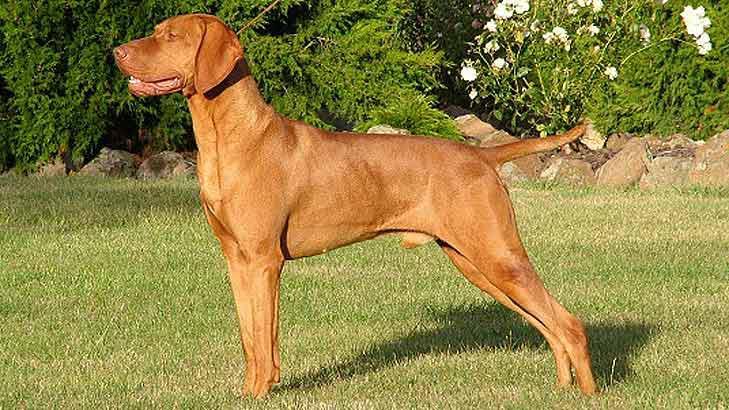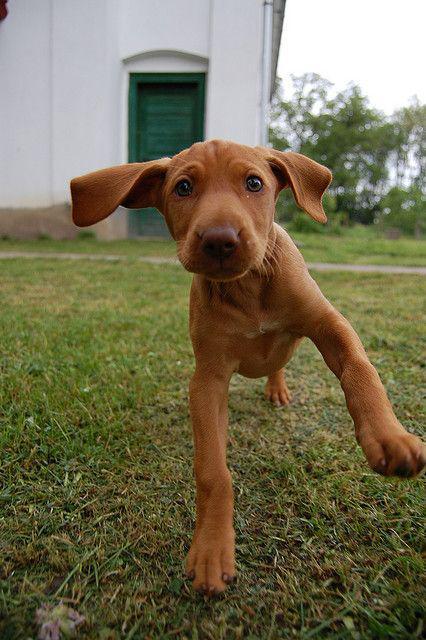The first image is the image on the left, the second image is the image on the right. Examine the images to the left and right. Is the description "In one of the images, there is a brown dog that is lying in the grass." accurate? Answer yes or no. No. 